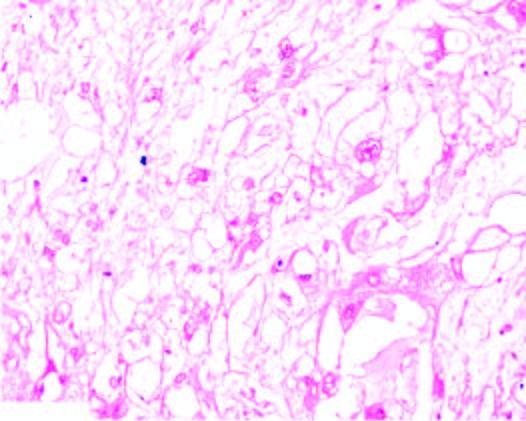what are quite variable in size having characteristic bubbly cytoplasm and anisonucleocytosis?
Answer the question using a single word or phrase. Tumour cells 